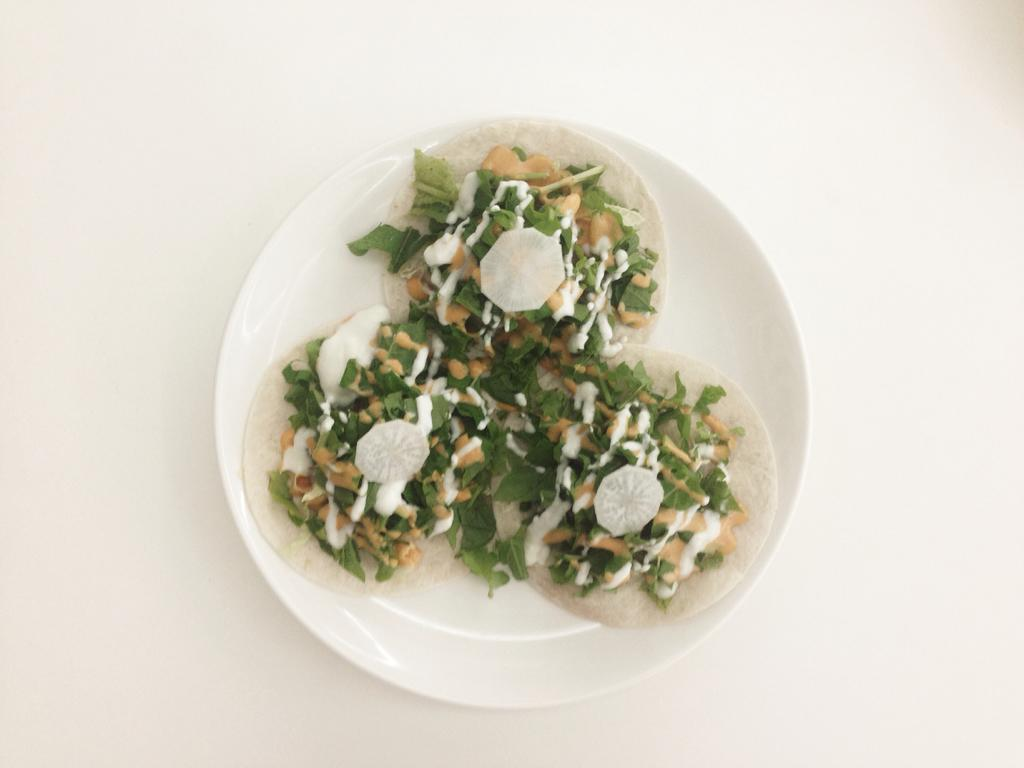What object is present on the table in the image? There is a plate on the table in the image. What is on the plate? There is a salad on the plate. What level of sand can be seen in the image? There is no sand present in the image. What arithmetic problem is being solved on the plate? There is no arithmetic problem present in the image; it features a plate with a salad on it. 